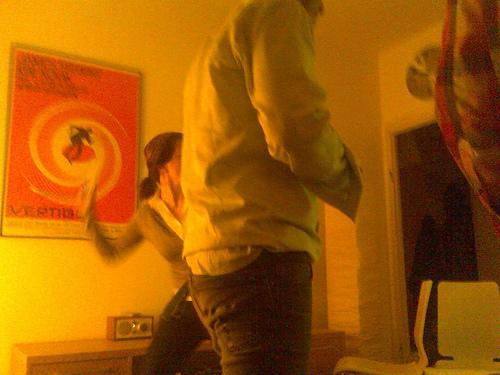What is the women about to do? Please explain your reasoning. play game. The women are playing wii. 